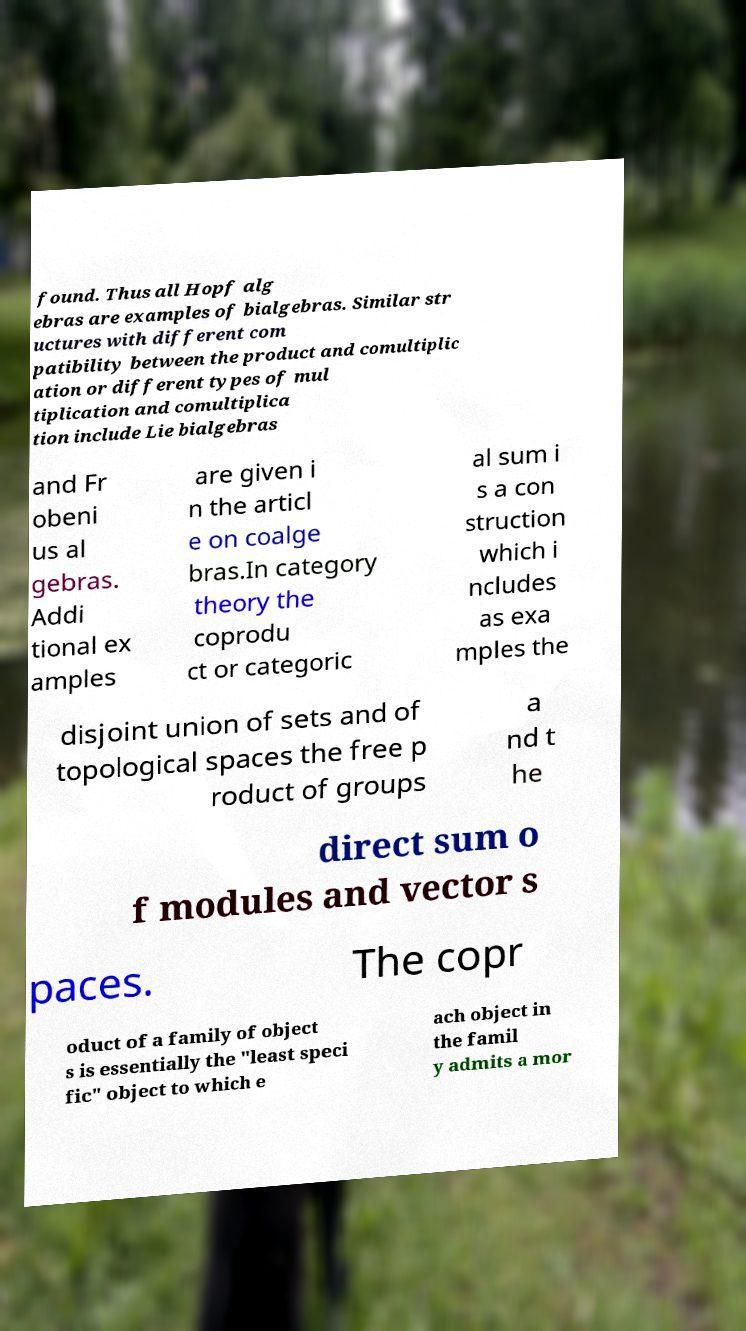Could you extract and type out the text from this image? found. Thus all Hopf alg ebras are examples of bialgebras. Similar str uctures with different com patibility between the product and comultiplic ation or different types of mul tiplication and comultiplica tion include Lie bialgebras and Fr obeni us al gebras. Addi tional ex amples are given i n the articl e on coalge bras.In category theory the coprodu ct or categoric al sum i s a con struction which i ncludes as exa mples the disjoint union of sets and of topological spaces the free p roduct of groups a nd t he direct sum o f modules and vector s paces. The copr oduct of a family of object s is essentially the "least speci fic" object to which e ach object in the famil y admits a mor 